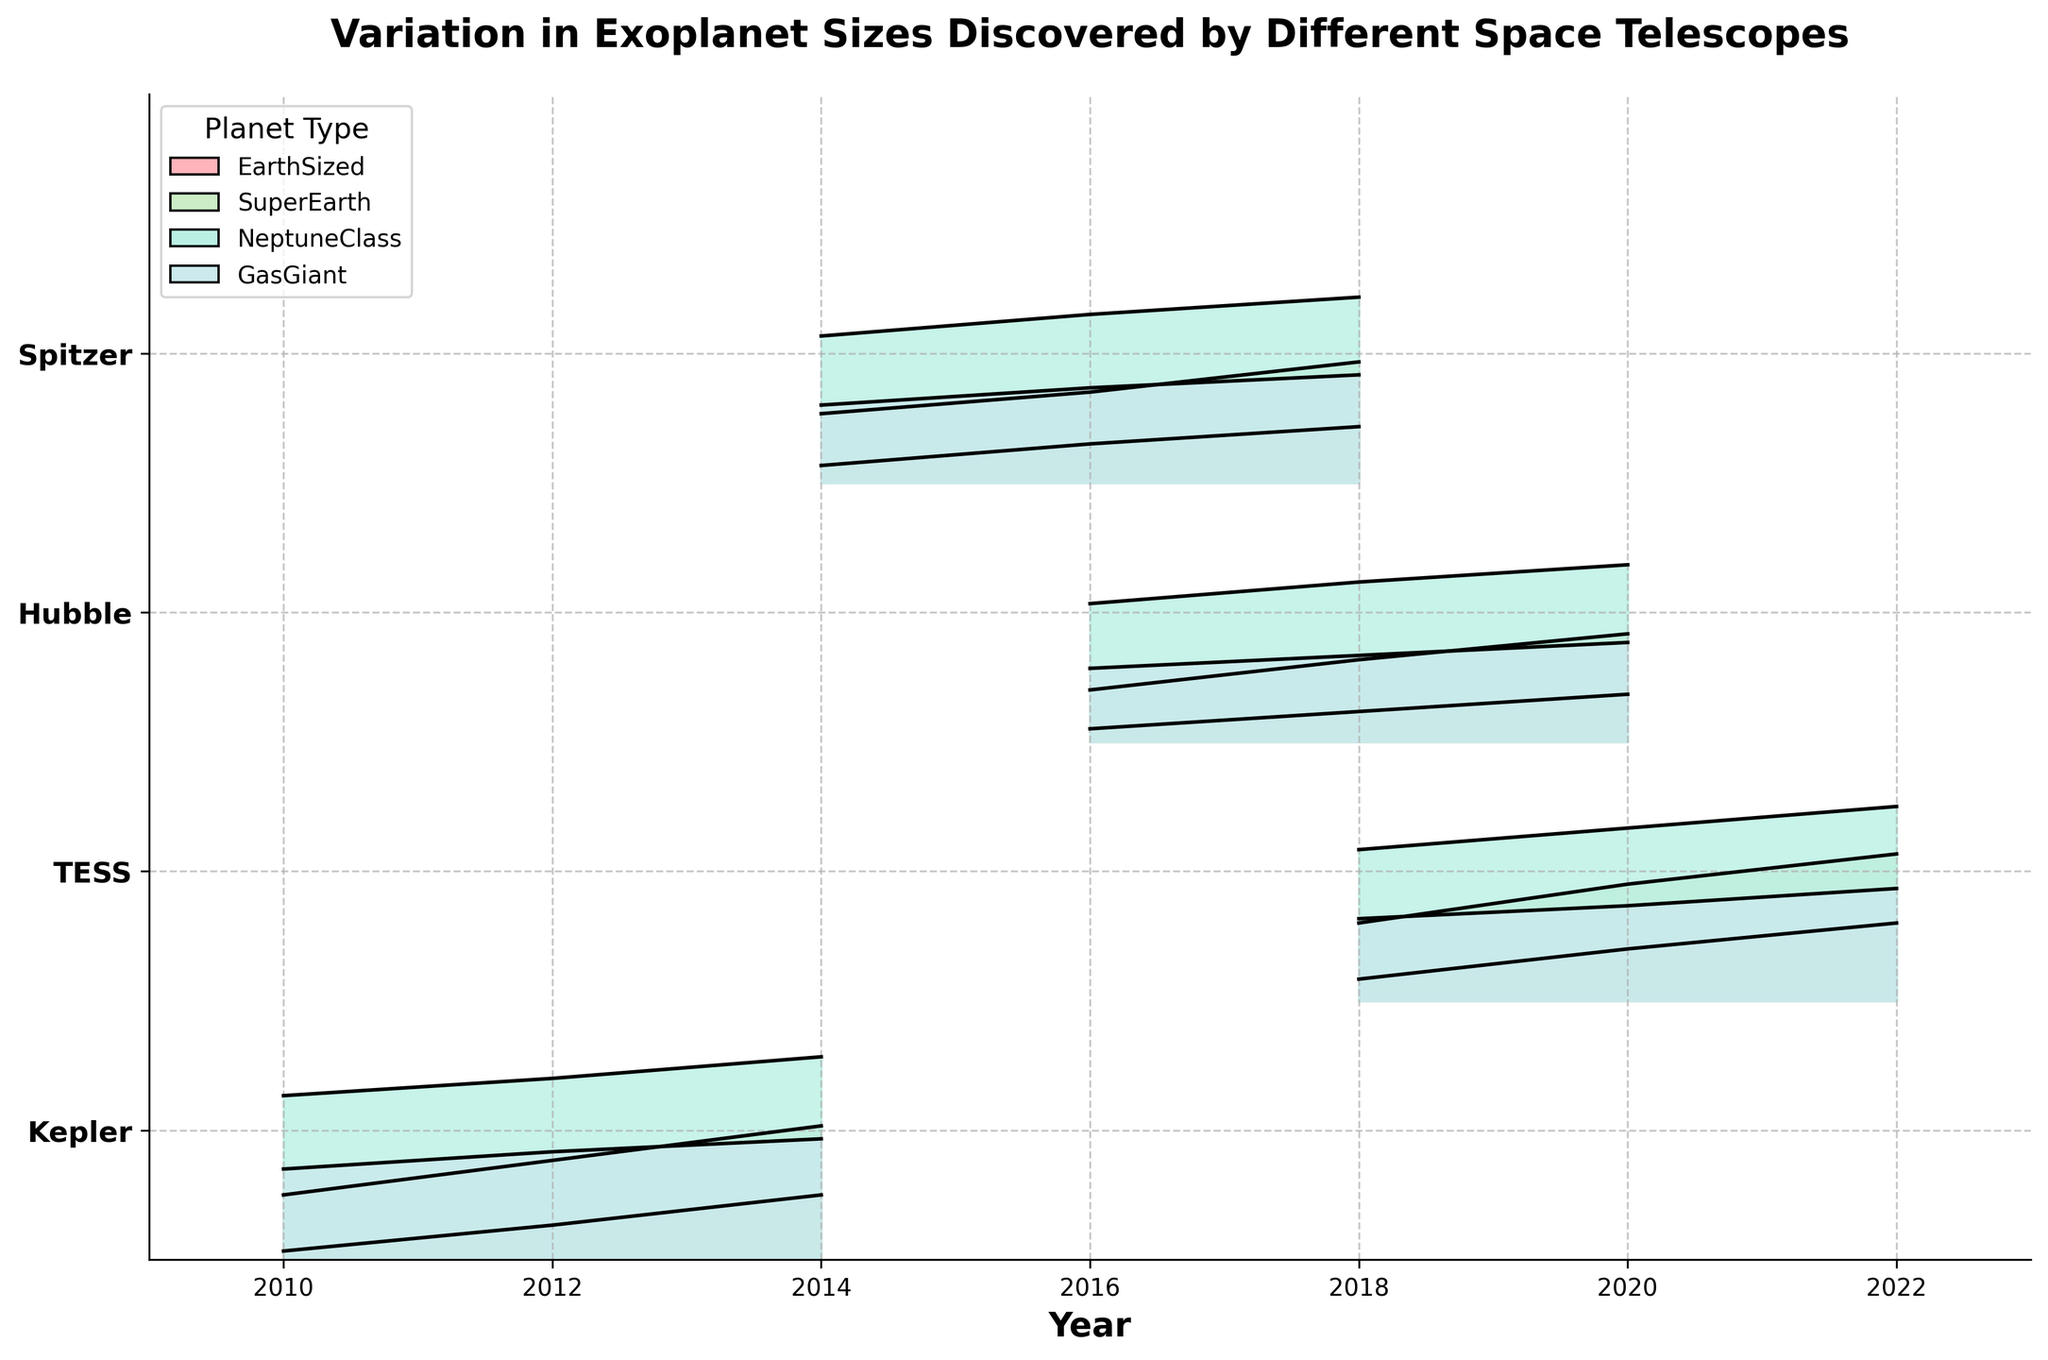what is the title of the plot? The title can be found at the top of the plot and usually describes what the plot is about. In this case, the title is "Variation in Exoplanet Sizes Discovered by Different Space Telescopes".
Answer: Variation in Exoplanet Sizes Discovered by Different Space Telescopes Which telescope has data spanning the most years on the plot? To determine this, one needs to look at each telescope and observe the range of years for which data is presented. Kepler has data points from 2010 to 2014, which is a span of 4 years. This is the longest span among the telescopes shown.
Answer: Kepler Which planet type has the highest values in the plot? The planet types are color-coded and named in the legend. By visually inspecting the height of the filled areas, Gas Giant consistently has the highest values across all telescopes and years.
Answer: Gas Giant How does the number of EarthSized exoplanets discovered by TESS change from 2018 to 2022? By observing the shades corresponding to EarthSized around the years 2018 and 2022 for TESS, we see that the value starts at 0.5 in 2018 and increases to 1.8 in 2022.
Answer: It increases from 0.5 to 1.8 Which year shows the highest discovery of SuperEarths by Hubble? To find this, look at the values for SuperEarths across different years for Hubble in the plot. The value is highest in the year 2020.
Answer: 2020 Which telescope shows the most consistent discovery rate for NeptuneClass exoplanets over its data range? Consistent discovery rate implies little variation in the NeptuneClass values over time. Inspecting the plot, Hubble shows relatively consistent levels for NeptuneClass exoplanets.
Answer: Hubble How do the discoveries of NeptuneClass exoplanets by Kepler change from 2010 to 2014? By observing the color gradient for NeptuneClass over these years for Kepler, we note that it starts at 3.8 in 2010 and goes up to 4.7 in 2014.
Answer: It increases from 3.8 to 4.7 Compare the discovery rates of Gas Giant exoplanets between Spitzer and TESS in 2018. By comparing the values for 2018 for both telescopes in the corresponding color shade for Gas Giants, Spitzer has a value of 2.5 and TESS has a value of 1.9. Therefore, Spitzer discovered more Gas Giants in that year.
Answer: Spitzer discovered more Are there any telescopes where the discovery of EarthSized planets is always the lowest among all planet types? By comparing all planet types' values for each telescope, it can be seen that in every year for Spitzer, EarthSized planets have the lowest values.
Answer: Spitzer What kind of trend can be observed in the discovery of SuperEarths by TESS from 2018 to 2022? Observing the plot for TESS, the values for SuperEarths increase from 1.8 in 2018 to 3.4 in 2022, indicating a gradually increasing trend.
Answer: An increasing trend 